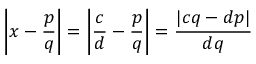<formula> <loc_0><loc_0><loc_500><loc_500>\left | x - { \frac { p } { q } } \right | = \left | { \frac { c } { d } } - { \frac { p } { q } } \right | = { \frac { | c q - d p | } { d q } }</formula> 